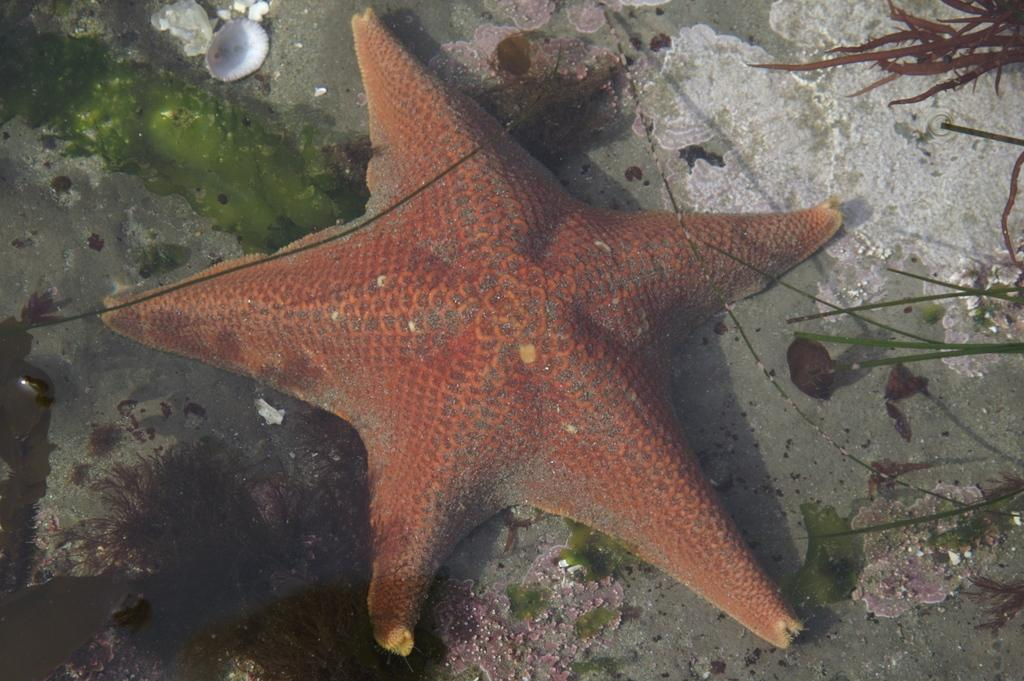What type of marine animal is in the image? There is a starfish in the image. What is covering the starfish? There is a shell around the starfish. What type of plant is visible in the image? There are grass leaves in the image. What other items can be seen in the image? There are other items visible in the image. What is the starfish's desire in the image? The starfish does not have desires, as it is an inanimate object in the image. 